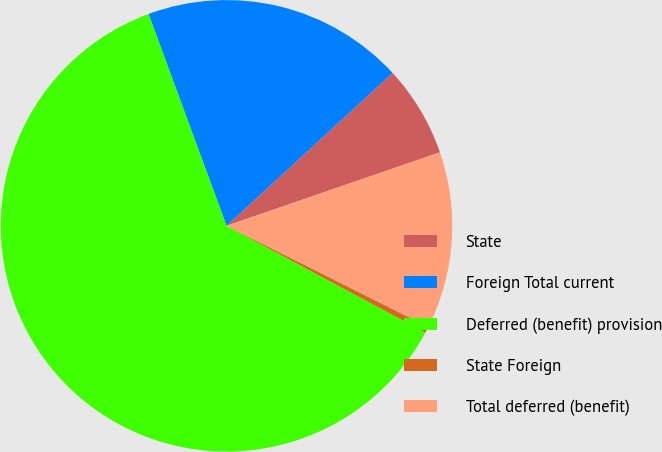<chart> <loc_0><loc_0><loc_500><loc_500><pie_chart><fcel>State<fcel>Foreign Total current<fcel>Deferred (benefit) provision<fcel>State Foreign<fcel>Total deferred (benefit)<nl><fcel>6.56%<fcel>18.78%<fcel>61.55%<fcel>0.45%<fcel>12.67%<nl></chart> 